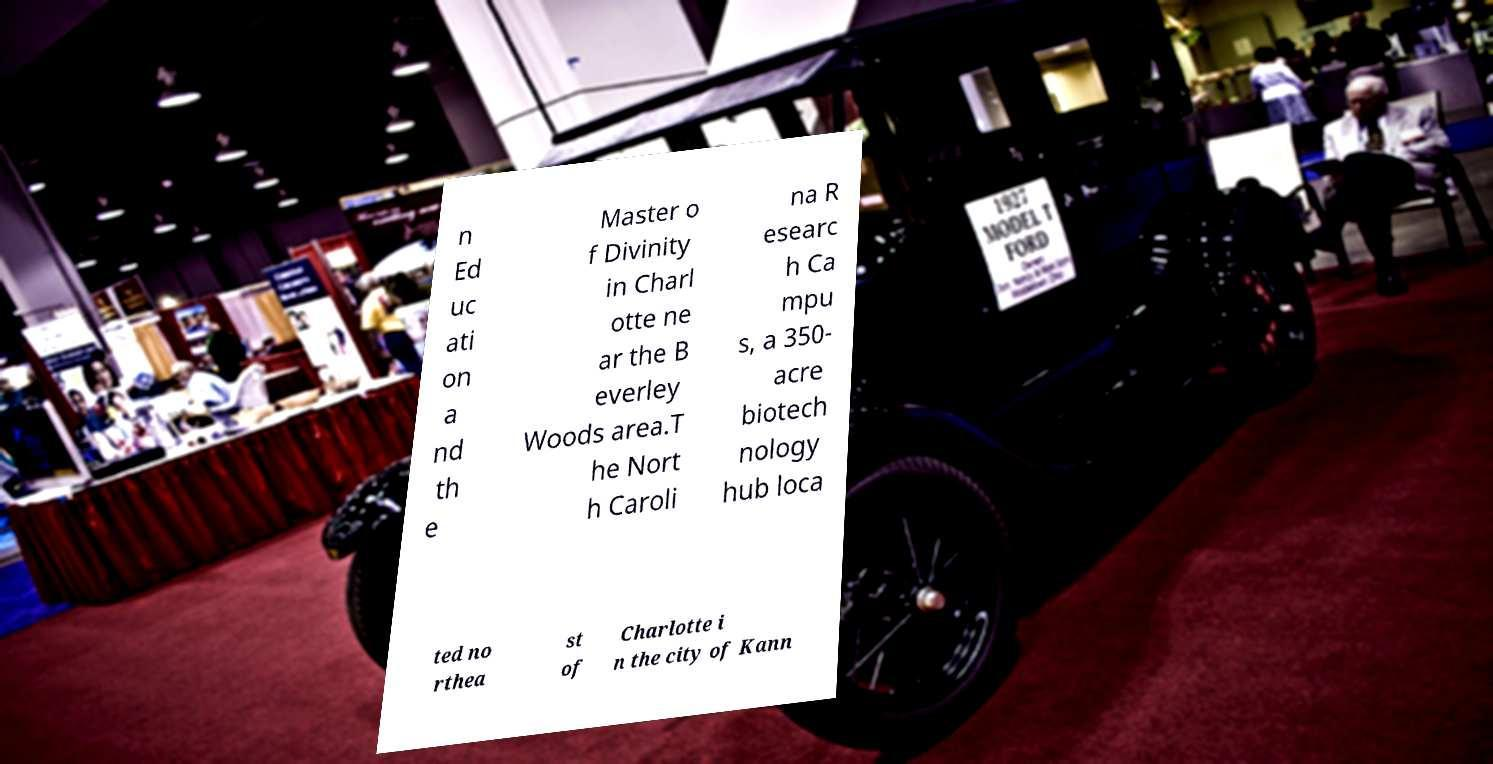I need the written content from this picture converted into text. Can you do that? n Ed uc ati on a nd th e Master o f Divinity in Charl otte ne ar the B everley Woods area.T he Nort h Caroli na R esearc h Ca mpu s, a 350- acre biotech nology hub loca ted no rthea st of Charlotte i n the city of Kann 